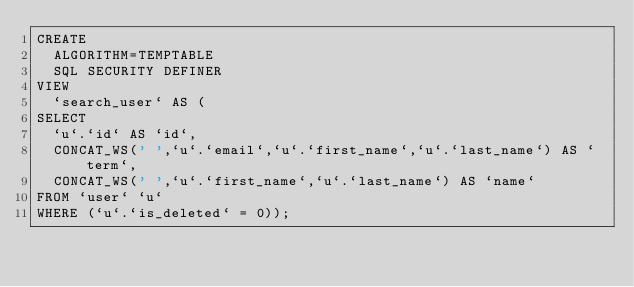<code> <loc_0><loc_0><loc_500><loc_500><_SQL_>CREATE
  ALGORITHM=TEMPTABLE
  SQL SECURITY DEFINER
VIEW
  `search_user` AS (
SELECT
  `u`.`id` AS `id`,
  CONCAT_WS(' ',`u`.`email`,`u`.`first_name`,`u`.`last_name`) AS `term`,
  CONCAT_WS(' ',`u`.`first_name`,`u`.`last_name`) AS `name`
FROM `user` `u`
WHERE (`u`.`is_deleted` = 0));
</code> 